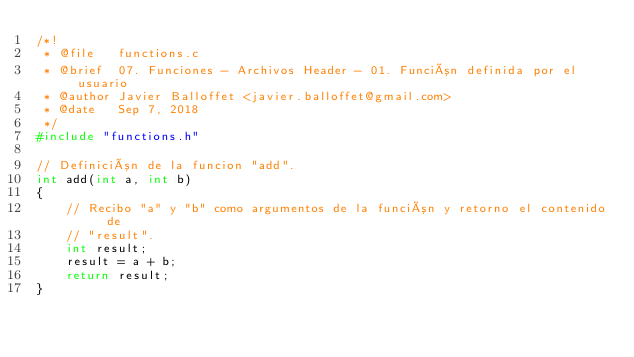Convert code to text. <code><loc_0><loc_0><loc_500><loc_500><_C_>/*!
 * @file   functions.c
 * @brief  07. Funciones - Archivos Header - 01. Función definida por el usuario
 * @author Javier Balloffet <javier.balloffet@gmail.com>
 * @date   Sep 7, 2018
 */
#include "functions.h"

// Definición de la funcion "add".
int add(int a, int b)
{
    // Recibo "a" y "b" como argumentos de la función y retorno el contenido de
    // "result".
    int result;
    result = a + b;
    return result;
}
</code> 